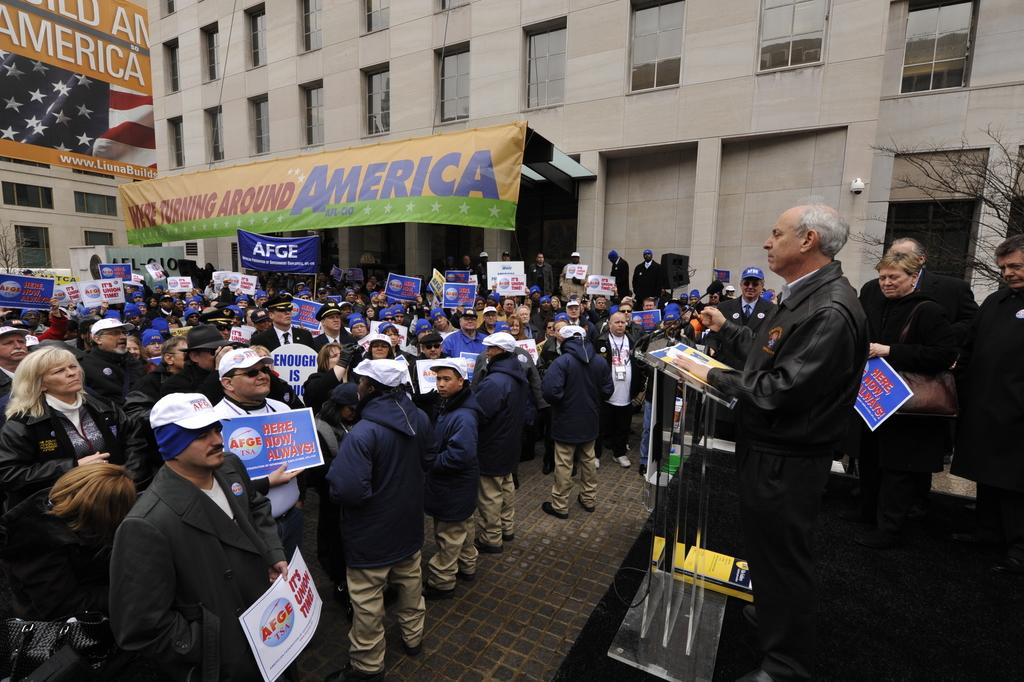What can be seen in the image? There are people, a podium with a microphone, a hoarding, a flag, trees, buildings, and a speaker visible in the image. What are the people holding in the image? The people are holding posters and a banner in the image. Can you describe the podium and microphone in the image? The podium is a stand with a microphone on top, which is typically used for public speaking or presentations. What type of pie is being served at the event in the image? There is no mention of pie or any food in the image. What is the chalk used for in the image? There is no chalk present in the image. 